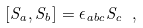<formula> <loc_0><loc_0><loc_500><loc_500>[ S _ { a } , S _ { b } ] = \epsilon _ { a b c } S _ { c } \ ,</formula> 